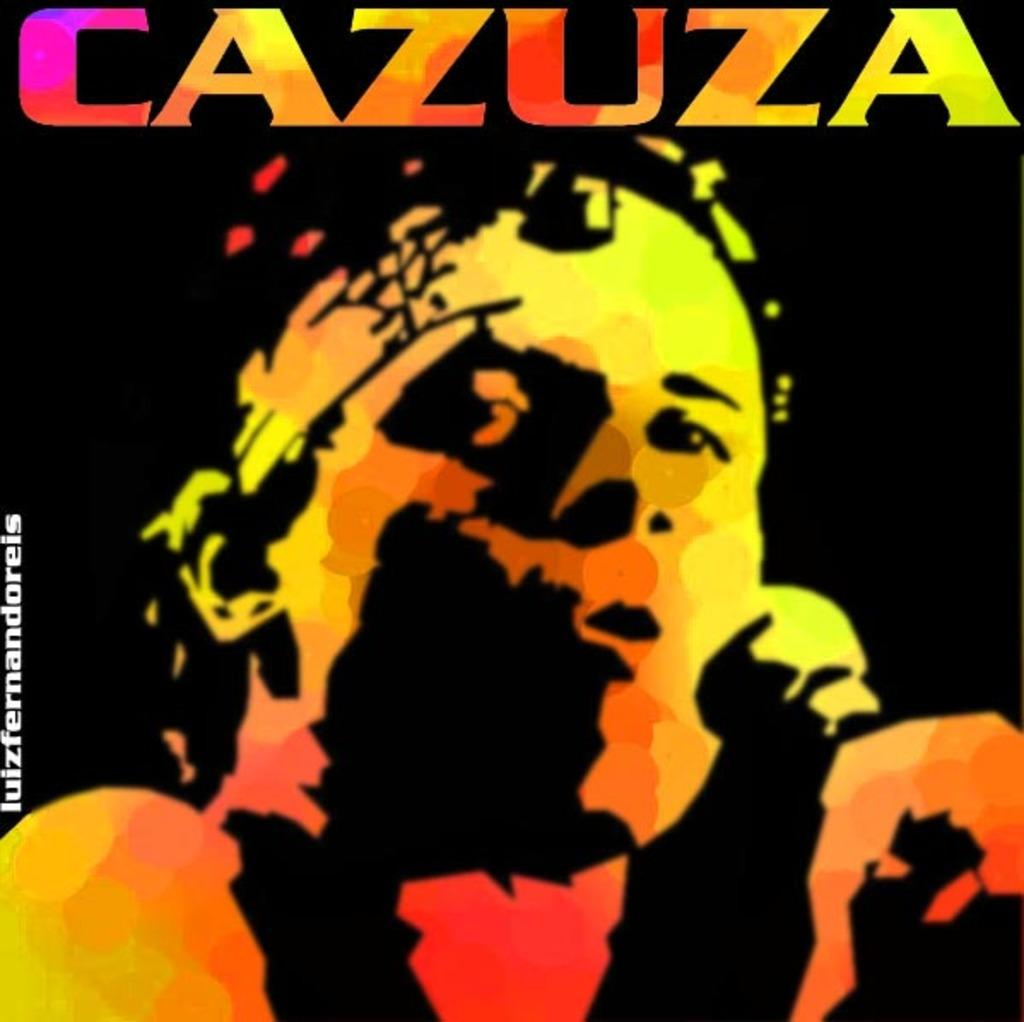Provide a one-sentence caption for the provided image. Cazuza with a microphone on a picture or a album cover. 